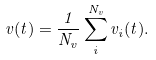<formula> <loc_0><loc_0><loc_500><loc_500>v ( t ) = \frac { 1 } { N _ { v } } \sum _ { i } ^ { N _ { v } } v _ { i } ( t ) .</formula> 